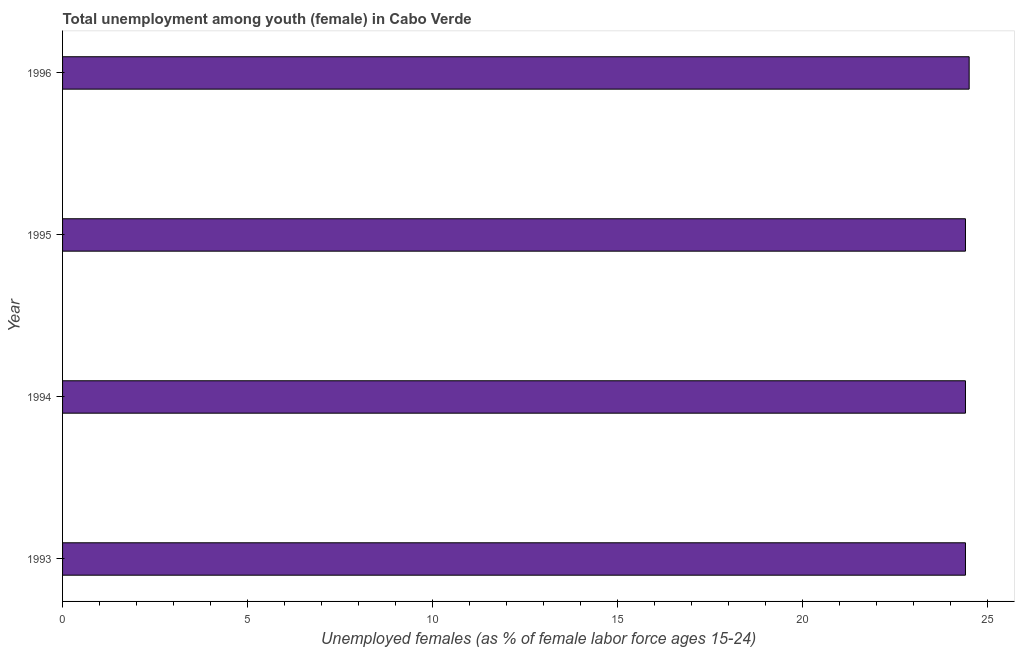Does the graph contain any zero values?
Keep it short and to the point. No. Does the graph contain grids?
Ensure brevity in your answer.  No. What is the title of the graph?
Provide a succinct answer. Total unemployment among youth (female) in Cabo Verde. What is the label or title of the X-axis?
Your answer should be compact. Unemployed females (as % of female labor force ages 15-24). What is the label or title of the Y-axis?
Provide a succinct answer. Year. What is the unemployed female youth population in 1993?
Provide a succinct answer. 24.4. Across all years, what is the maximum unemployed female youth population?
Provide a succinct answer. 24.5. Across all years, what is the minimum unemployed female youth population?
Your answer should be compact. 24.4. In which year was the unemployed female youth population maximum?
Your answer should be very brief. 1996. What is the sum of the unemployed female youth population?
Offer a very short reply. 97.7. What is the average unemployed female youth population per year?
Keep it short and to the point. 24.43. What is the median unemployed female youth population?
Your answer should be compact. 24.4. In how many years, is the unemployed female youth population greater than 12 %?
Your answer should be very brief. 4. What is the ratio of the unemployed female youth population in 1994 to that in 1995?
Offer a terse response. 1. Is the difference between the unemployed female youth population in 1994 and 1996 greater than the difference between any two years?
Make the answer very short. Yes. In how many years, is the unemployed female youth population greater than the average unemployed female youth population taken over all years?
Offer a terse response. 1. How many years are there in the graph?
Make the answer very short. 4. Are the values on the major ticks of X-axis written in scientific E-notation?
Offer a very short reply. No. What is the Unemployed females (as % of female labor force ages 15-24) in 1993?
Your answer should be compact. 24.4. What is the Unemployed females (as % of female labor force ages 15-24) of 1994?
Ensure brevity in your answer.  24.4. What is the Unemployed females (as % of female labor force ages 15-24) in 1995?
Provide a succinct answer. 24.4. What is the difference between the Unemployed females (as % of female labor force ages 15-24) in 1993 and 1995?
Make the answer very short. 0. What is the difference between the Unemployed females (as % of female labor force ages 15-24) in 1993 and 1996?
Ensure brevity in your answer.  -0.1. What is the difference between the Unemployed females (as % of female labor force ages 15-24) in 1994 and 1996?
Your answer should be compact. -0.1. What is the ratio of the Unemployed females (as % of female labor force ages 15-24) in 1994 to that in 1996?
Offer a very short reply. 1. What is the ratio of the Unemployed females (as % of female labor force ages 15-24) in 1995 to that in 1996?
Your response must be concise. 1. 